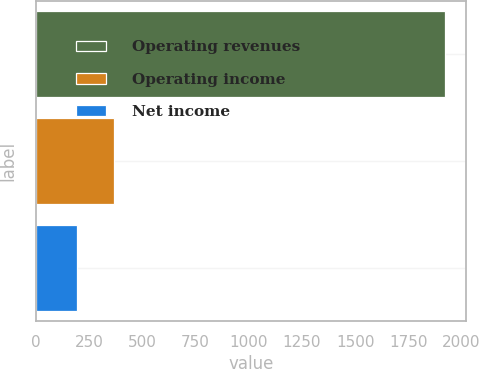<chart> <loc_0><loc_0><loc_500><loc_500><bar_chart><fcel>Operating revenues<fcel>Operating income<fcel>Net income<nl><fcel>1923<fcel>365.1<fcel>192<nl></chart> 